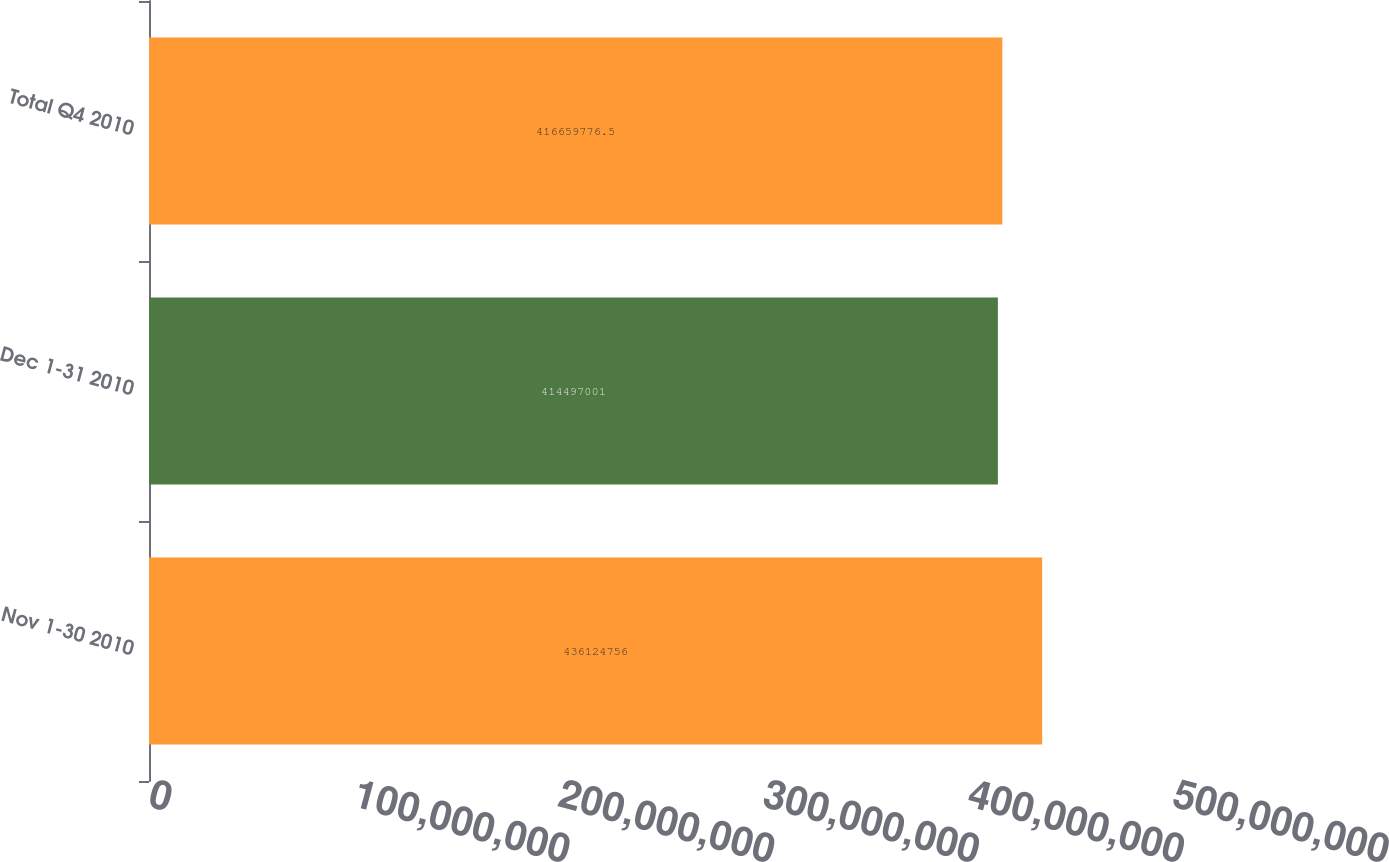Convert chart to OTSL. <chart><loc_0><loc_0><loc_500><loc_500><bar_chart><fcel>Nov 1-30 2010<fcel>Dec 1-31 2010<fcel>Total Q4 2010<nl><fcel>4.36125e+08<fcel>4.14497e+08<fcel>4.1666e+08<nl></chart> 